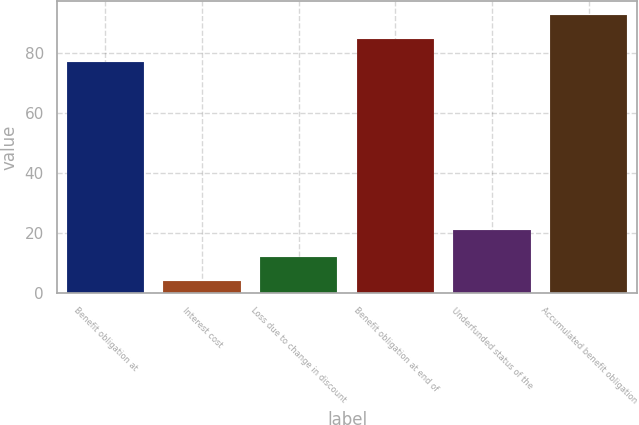Convert chart. <chart><loc_0><loc_0><loc_500><loc_500><bar_chart><fcel>Benefit obligation at<fcel>Interest cost<fcel>Loss due to change in discount<fcel>Benefit obligation at end of<fcel>Underfunded status of the<fcel>Accumulated benefit obligation<nl><fcel>77<fcel>4<fcel>11.9<fcel>84.9<fcel>21<fcel>92.8<nl></chart> 